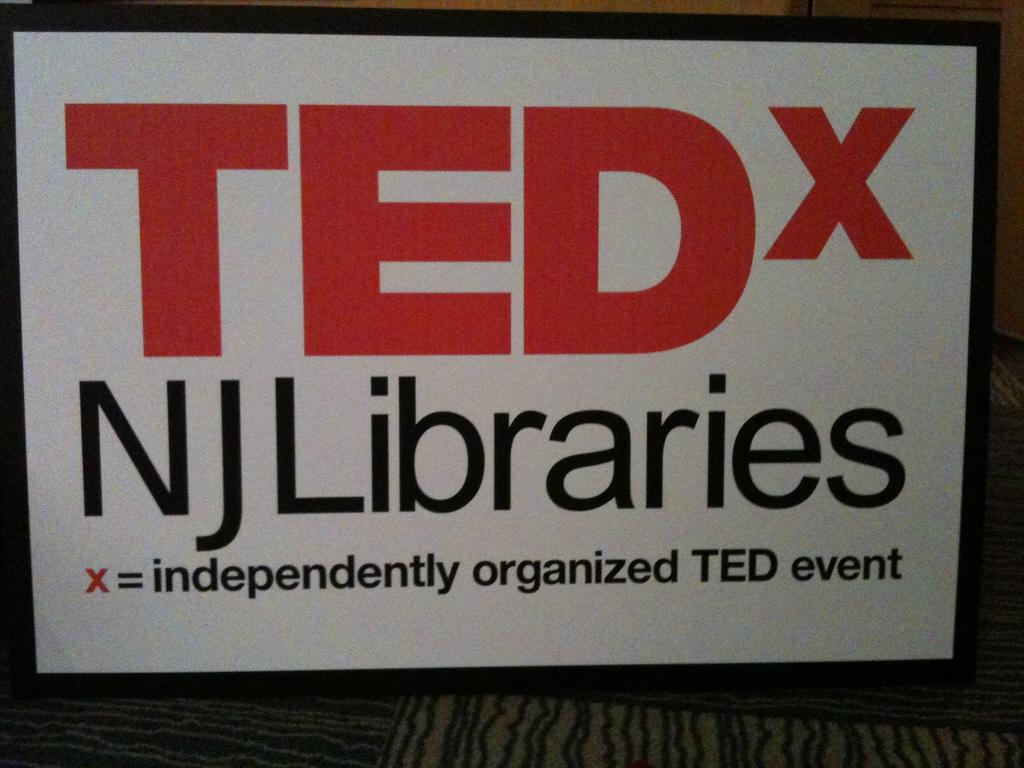Provide a one-sentence caption for the provided image. The x in the image indicates it's an independently organized event. 